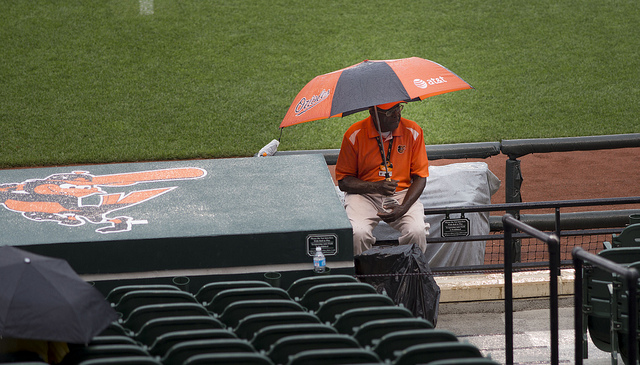Can you describe the logo visible on the umbrella and the seat? The logo on the umbrella and on the seat cover depicts the Baltimore Orioles, indicated by the bird silhouette and distinctive script style. 